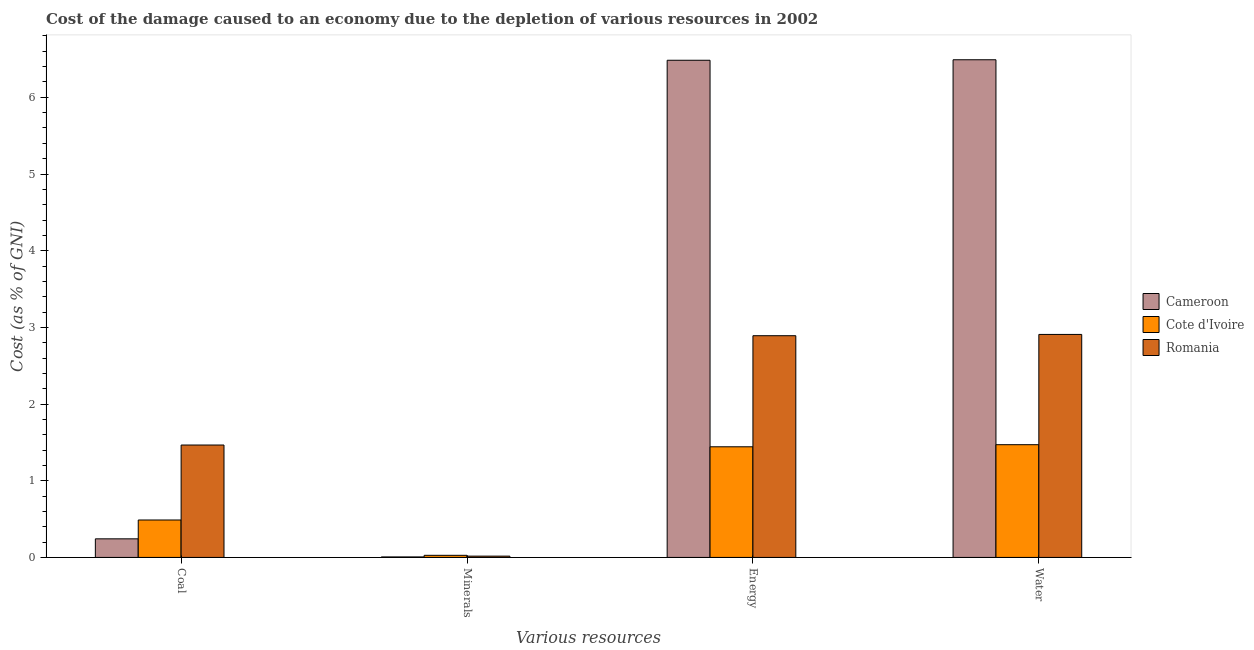Are the number of bars on each tick of the X-axis equal?
Provide a succinct answer. Yes. How many bars are there on the 3rd tick from the left?
Provide a succinct answer. 3. What is the label of the 1st group of bars from the left?
Your answer should be compact. Coal. What is the cost of damage due to depletion of minerals in Romania?
Offer a terse response. 0.02. Across all countries, what is the maximum cost of damage due to depletion of water?
Provide a succinct answer. 6.49. Across all countries, what is the minimum cost of damage due to depletion of minerals?
Give a very brief answer. 0.01. In which country was the cost of damage due to depletion of coal maximum?
Your answer should be compact. Romania. In which country was the cost of damage due to depletion of energy minimum?
Offer a very short reply. Cote d'Ivoire. What is the total cost of damage due to depletion of energy in the graph?
Your answer should be very brief. 10.82. What is the difference between the cost of damage due to depletion of coal in Cameroon and that in Romania?
Your answer should be compact. -1.22. What is the difference between the cost of damage due to depletion of coal in Cote d'Ivoire and the cost of damage due to depletion of energy in Romania?
Offer a terse response. -2.4. What is the average cost of damage due to depletion of water per country?
Offer a terse response. 3.62. What is the difference between the cost of damage due to depletion of water and cost of damage due to depletion of minerals in Cameroon?
Your answer should be compact. 6.48. What is the ratio of the cost of damage due to depletion of energy in Cote d'Ivoire to that in Cameroon?
Provide a succinct answer. 0.22. What is the difference between the highest and the second highest cost of damage due to depletion of water?
Give a very brief answer. 3.58. What is the difference between the highest and the lowest cost of damage due to depletion of energy?
Offer a terse response. 5.04. Is it the case that in every country, the sum of the cost of damage due to depletion of coal and cost of damage due to depletion of energy is greater than the sum of cost of damage due to depletion of minerals and cost of damage due to depletion of water?
Your answer should be very brief. Yes. What does the 2nd bar from the left in Water represents?
Offer a very short reply. Cote d'Ivoire. What does the 3rd bar from the right in Minerals represents?
Offer a terse response. Cameroon. How many bars are there?
Make the answer very short. 12. How many countries are there in the graph?
Provide a short and direct response. 3. What is the difference between two consecutive major ticks on the Y-axis?
Keep it short and to the point. 1. Are the values on the major ticks of Y-axis written in scientific E-notation?
Offer a very short reply. No. Does the graph contain any zero values?
Offer a very short reply. No. Does the graph contain grids?
Give a very brief answer. No. Where does the legend appear in the graph?
Make the answer very short. Center right. How many legend labels are there?
Provide a succinct answer. 3. What is the title of the graph?
Provide a succinct answer. Cost of the damage caused to an economy due to the depletion of various resources in 2002 . Does "Ethiopia" appear as one of the legend labels in the graph?
Your answer should be compact. No. What is the label or title of the X-axis?
Provide a succinct answer. Various resources. What is the label or title of the Y-axis?
Provide a succinct answer. Cost (as % of GNI). What is the Cost (as % of GNI) in Cameroon in Coal?
Keep it short and to the point. 0.24. What is the Cost (as % of GNI) in Cote d'Ivoire in Coal?
Your response must be concise. 0.49. What is the Cost (as % of GNI) of Romania in Coal?
Your answer should be compact. 1.47. What is the Cost (as % of GNI) in Cameroon in Minerals?
Your answer should be compact. 0.01. What is the Cost (as % of GNI) of Cote d'Ivoire in Minerals?
Keep it short and to the point. 0.03. What is the Cost (as % of GNI) of Romania in Minerals?
Provide a short and direct response. 0.02. What is the Cost (as % of GNI) in Cameroon in Energy?
Ensure brevity in your answer.  6.48. What is the Cost (as % of GNI) of Cote d'Ivoire in Energy?
Make the answer very short. 1.44. What is the Cost (as % of GNI) in Romania in Energy?
Your answer should be very brief. 2.89. What is the Cost (as % of GNI) of Cameroon in Water?
Provide a short and direct response. 6.49. What is the Cost (as % of GNI) in Cote d'Ivoire in Water?
Keep it short and to the point. 1.47. What is the Cost (as % of GNI) of Romania in Water?
Your answer should be very brief. 2.91. Across all Various resources, what is the maximum Cost (as % of GNI) in Cameroon?
Ensure brevity in your answer.  6.49. Across all Various resources, what is the maximum Cost (as % of GNI) in Cote d'Ivoire?
Offer a terse response. 1.47. Across all Various resources, what is the maximum Cost (as % of GNI) in Romania?
Ensure brevity in your answer.  2.91. Across all Various resources, what is the minimum Cost (as % of GNI) in Cameroon?
Keep it short and to the point. 0.01. Across all Various resources, what is the minimum Cost (as % of GNI) in Cote d'Ivoire?
Ensure brevity in your answer.  0.03. Across all Various resources, what is the minimum Cost (as % of GNI) in Romania?
Ensure brevity in your answer.  0.02. What is the total Cost (as % of GNI) in Cameroon in the graph?
Provide a succinct answer. 13.22. What is the total Cost (as % of GNI) of Cote d'Ivoire in the graph?
Provide a succinct answer. 3.43. What is the total Cost (as % of GNI) of Romania in the graph?
Provide a succinct answer. 7.28. What is the difference between the Cost (as % of GNI) of Cameroon in Coal and that in Minerals?
Provide a succinct answer. 0.24. What is the difference between the Cost (as % of GNI) of Cote d'Ivoire in Coal and that in Minerals?
Provide a short and direct response. 0.46. What is the difference between the Cost (as % of GNI) of Romania in Coal and that in Minerals?
Your response must be concise. 1.45. What is the difference between the Cost (as % of GNI) of Cameroon in Coal and that in Energy?
Give a very brief answer. -6.24. What is the difference between the Cost (as % of GNI) of Cote d'Ivoire in Coal and that in Energy?
Give a very brief answer. -0.95. What is the difference between the Cost (as % of GNI) of Romania in Coal and that in Energy?
Your answer should be compact. -1.43. What is the difference between the Cost (as % of GNI) in Cameroon in Coal and that in Water?
Your response must be concise. -6.25. What is the difference between the Cost (as % of GNI) of Cote d'Ivoire in Coal and that in Water?
Offer a terse response. -0.98. What is the difference between the Cost (as % of GNI) of Romania in Coal and that in Water?
Offer a very short reply. -1.44. What is the difference between the Cost (as % of GNI) of Cameroon in Minerals and that in Energy?
Offer a very short reply. -6.48. What is the difference between the Cost (as % of GNI) of Cote d'Ivoire in Minerals and that in Energy?
Offer a terse response. -1.42. What is the difference between the Cost (as % of GNI) in Romania in Minerals and that in Energy?
Ensure brevity in your answer.  -2.87. What is the difference between the Cost (as % of GNI) in Cameroon in Minerals and that in Water?
Your response must be concise. -6.48. What is the difference between the Cost (as % of GNI) of Cote d'Ivoire in Minerals and that in Water?
Offer a very short reply. -1.44. What is the difference between the Cost (as % of GNI) in Romania in Minerals and that in Water?
Make the answer very short. -2.89. What is the difference between the Cost (as % of GNI) of Cameroon in Energy and that in Water?
Offer a very short reply. -0.01. What is the difference between the Cost (as % of GNI) of Cote d'Ivoire in Energy and that in Water?
Keep it short and to the point. -0.03. What is the difference between the Cost (as % of GNI) in Romania in Energy and that in Water?
Keep it short and to the point. -0.02. What is the difference between the Cost (as % of GNI) in Cameroon in Coal and the Cost (as % of GNI) in Cote d'Ivoire in Minerals?
Provide a succinct answer. 0.21. What is the difference between the Cost (as % of GNI) in Cameroon in Coal and the Cost (as % of GNI) in Romania in Minerals?
Provide a succinct answer. 0.23. What is the difference between the Cost (as % of GNI) in Cote d'Ivoire in Coal and the Cost (as % of GNI) in Romania in Minerals?
Your answer should be very brief. 0.47. What is the difference between the Cost (as % of GNI) in Cameroon in Coal and the Cost (as % of GNI) in Cote d'Ivoire in Energy?
Your answer should be very brief. -1.2. What is the difference between the Cost (as % of GNI) in Cameroon in Coal and the Cost (as % of GNI) in Romania in Energy?
Provide a short and direct response. -2.65. What is the difference between the Cost (as % of GNI) of Cote d'Ivoire in Coal and the Cost (as % of GNI) of Romania in Energy?
Keep it short and to the point. -2.4. What is the difference between the Cost (as % of GNI) of Cameroon in Coal and the Cost (as % of GNI) of Cote d'Ivoire in Water?
Give a very brief answer. -1.23. What is the difference between the Cost (as % of GNI) in Cameroon in Coal and the Cost (as % of GNI) in Romania in Water?
Your answer should be compact. -2.67. What is the difference between the Cost (as % of GNI) of Cote d'Ivoire in Coal and the Cost (as % of GNI) of Romania in Water?
Your response must be concise. -2.42. What is the difference between the Cost (as % of GNI) in Cameroon in Minerals and the Cost (as % of GNI) in Cote d'Ivoire in Energy?
Provide a short and direct response. -1.44. What is the difference between the Cost (as % of GNI) of Cameroon in Minerals and the Cost (as % of GNI) of Romania in Energy?
Provide a short and direct response. -2.88. What is the difference between the Cost (as % of GNI) in Cote d'Ivoire in Minerals and the Cost (as % of GNI) in Romania in Energy?
Your answer should be very brief. -2.86. What is the difference between the Cost (as % of GNI) of Cameroon in Minerals and the Cost (as % of GNI) of Cote d'Ivoire in Water?
Offer a terse response. -1.46. What is the difference between the Cost (as % of GNI) in Cameroon in Minerals and the Cost (as % of GNI) in Romania in Water?
Offer a terse response. -2.9. What is the difference between the Cost (as % of GNI) of Cote d'Ivoire in Minerals and the Cost (as % of GNI) of Romania in Water?
Your response must be concise. -2.88. What is the difference between the Cost (as % of GNI) in Cameroon in Energy and the Cost (as % of GNI) in Cote d'Ivoire in Water?
Provide a short and direct response. 5.01. What is the difference between the Cost (as % of GNI) in Cameroon in Energy and the Cost (as % of GNI) in Romania in Water?
Your answer should be compact. 3.58. What is the difference between the Cost (as % of GNI) in Cote d'Ivoire in Energy and the Cost (as % of GNI) in Romania in Water?
Make the answer very short. -1.47. What is the average Cost (as % of GNI) of Cameroon per Various resources?
Keep it short and to the point. 3.31. What is the average Cost (as % of GNI) in Cote d'Ivoire per Various resources?
Offer a very short reply. 0.86. What is the average Cost (as % of GNI) of Romania per Various resources?
Your response must be concise. 1.82. What is the difference between the Cost (as % of GNI) of Cameroon and Cost (as % of GNI) of Cote d'Ivoire in Coal?
Provide a short and direct response. -0.25. What is the difference between the Cost (as % of GNI) in Cameroon and Cost (as % of GNI) in Romania in Coal?
Keep it short and to the point. -1.22. What is the difference between the Cost (as % of GNI) of Cote d'Ivoire and Cost (as % of GNI) of Romania in Coal?
Provide a short and direct response. -0.98. What is the difference between the Cost (as % of GNI) of Cameroon and Cost (as % of GNI) of Cote d'Ivoire in Minerals?
Keep it short and to the point. -0.02. What is the difference between the Cost (as % of GNI) in Cameroon and Cost (as % of GNI) in Romania in Minerals?
Your answer should be very brief. -0.01. What is the difference between the Cost (as % of GNI) in Cote d'Ivoire and Cost (as % of GNI) in Romania in Minerals?
Offer a terse response. 0.01. What is the difference between the Cost (as % of GNI) of Cameroon and Cost (as % of GNI) of Cote d'Ivoire in Energy?
Provide a succinct answer. 5.04. What is the difference between the Cost (as % of GNI) of Cameroon and Cost (as % of GNI) of Romania in Energy?
Make the answer very short. 3.59. What is the difference between the Cost (as % of GNI) of Cote d'Ivoire and Cost (as % of GNI) of Romania in Energy?
Your answer should be compact. -1.45. What is the difference between the Cost (as % of GNI) of Cameroon and Cost (as % of GNI) of Cote d'Ivoire in Water?
Make the answer very short. 5.02. What is the difference between the Cost (as % of GNI) of Cameroon and Cost (as % of GNI) of Romania in Water?
Provide a short and direct response. 3.58. What is the difference between the Cost (as % of GNI) of Cote d'Ivoire and Cost (as % of GNI) of Romania in Water?
Your response must be concise. -1.44. What is the ratio of the Cost (as % of GNI) in Cameroon in Coal to that in Minerals?
Give a very brief answer. 36.94. What is the ratio of the Cost (as % of GNI) in Cote d'Ivoire in Coal to that in Minerals?
Your answer should be compact. 17.82. What is the ratio of the Cost (as % of GNI) of Romania in Coal to that in Minerals?
Your answer should be compact. 86.92. What is the ratio of the Cost (as % of GNI) in Cameroon in Coal to that in Energy?
Provide a short and direct response. 0.04. What is the ratio of the Cost (as % of GNI) of Cote d'Ivoire in Coal to that in Energy?
Your answer should be compact. 0.34. What is the ratio of the Cost (as % of GNI) in Romania in Coal to that in Energy?
Offer a terse response. 0.51. What is the ratio of the Cost (as % of GNI) in Cameroon in Coal to that in Water?
Provide a short and direct response. 0.04. What is the ratio of the Cost (as % of GNI) of Cote d'Ivoire in Coal to that in Water?
Your response must be concise. 0.33. What is the ratio of the Cost (as % of GNI) in Romania in Coal to that in Water?
Your response must be concise. 0.5. What is the ratio of the Cost (as % of GNI) in Cote d'Ivoire in Minerals to that in Energy?
Make the answer very short. 0.02. What is the ratio of the Cost (as % of GNI) in Romania in Minerals to that in Energy?
Keep it short and to the point. 0.01. What is the ratio of the Cost (as % of GNI) of Cote d'Ivoire in Minerals to that in Water?
Your answer should be compact. 0.02. What is the ratio of the Cost (as % of GNI) in Romania in Minerals to that in Water?
Ensure brevity in your answer.  0.01. What is the ratio of the Cost (as % of GNI) in Cameroon in Energy to that in Water?
Ensure brevity in your answer.  1. What is the ratio of the Cost (as % of GNI) in Cote d'Ivoire in Energy to that in Water?
Offer a very short reply. 0.98. What is the ratio of the Cost (as % of GNI) in Romania in Energy to that in Water?
Provide a short and direct response. 0.99. What is the difference between the highest and the second highest Cost (as % of GNI) in Cameroon?
Your answer should be very brief. 0.01. What is the difference between the highest and the second highest Cost (as % of GNI) of Cote d'Ivoire?
Provide a succinct answer. 0.03. What is the difference between the highest and the second highest Cost (as % of GNI) in Romania?
Provide a succinct answer. 0.02. What is the difference between the highest and the lowest Cost (as % of GNI) of Cameroon?
Give a very brief answer. 6.48. What is the difference between the highest and the lowest Cost (as % of GNI) in Cote d'Ivoire?
Provide a succinct answer. 1.44. What is the difference between the highest and the lowest Cost (as % of GNI) in Romania?
Your answer should be very brief. 2.89. 